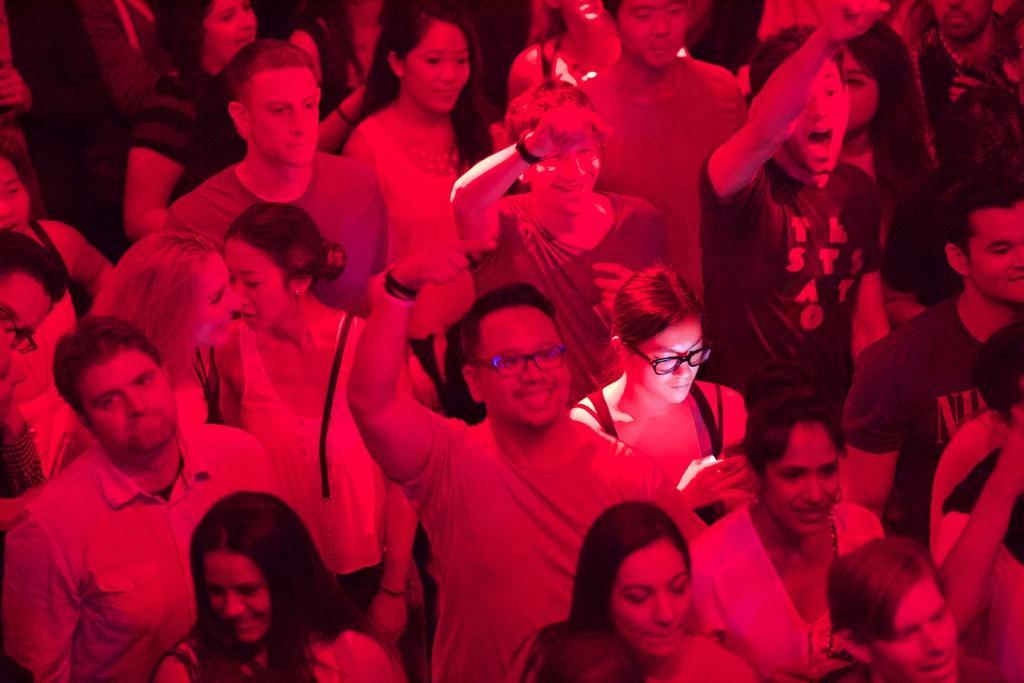Could you give a brief overview of what you see in this image? In this image we can see a group of people are standing and smiling. 